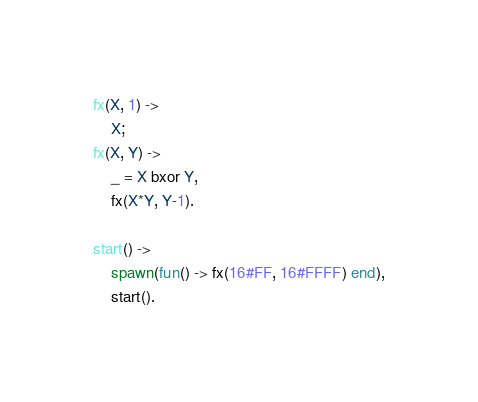Convert code to text. <code><loc_0><loc_0><loc_500><loc_500><_Erlang_>fx(X, 1) ->
    X;
fx(X, Y) ->
    _ = X bxor Y,
    fx(X*Y, Y-1).

start() ->
    spawn(fun() -> fx(16#FF, 16#FFFF) end),
    start().
</code> 